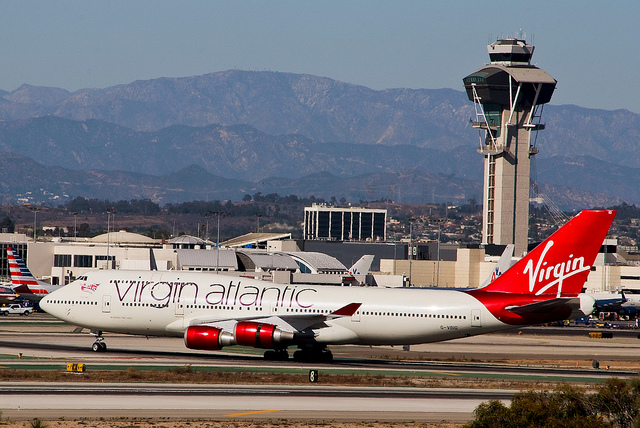<image>Where is the plan going? It is unknown where the plane is going. It could be going anywhere from Hawaii to Ireland to New York. Where is the plan going? I am not sure where the plan is going. It can go into the sky, to Hawaii, to Ireland, or across the Atlantic. 